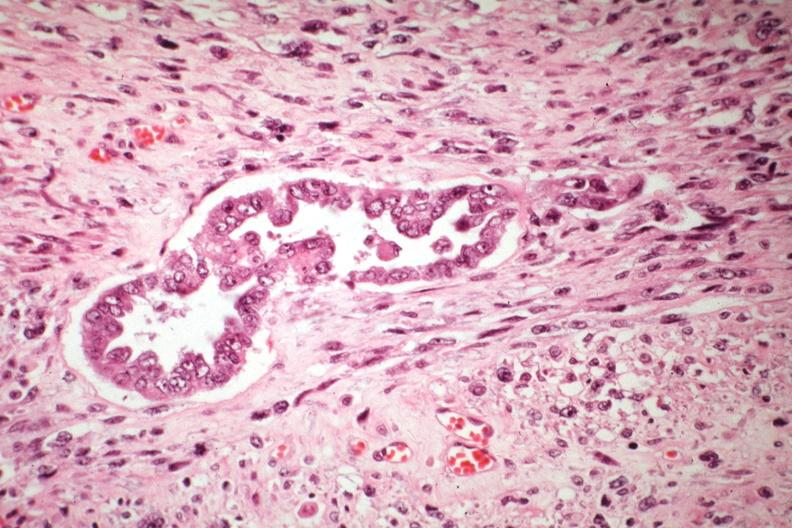does coronary artery show malignant gland and stoma well shown?
Answer the question using a single word or phrase. No 